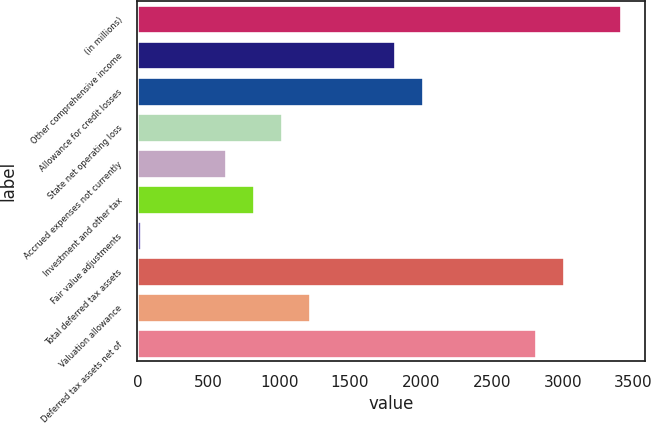Convert chart to OTSL. <chart><loc_0><loc_0><loc_500><loc_500><bar_chart><fcel>(in millions)<fcel>Other comprehensive income<fcel>Allowance for credit losses<fcel>State net operating loss<fcel>Accrued expenses not currently<fcel>Investment and other tax<fcel>Fair value adjustments<fcel>Total deferred tax assets<fcel>Valuation allowance<fcel>Deferred tax assets net of<nl><fcel>3410<fcel>1818<fcel>2017<fcel>1022<fcel>624<fcel>823<fcel>27<fcel>3012<fcel>1221<fcel>2813<nl></chart> 